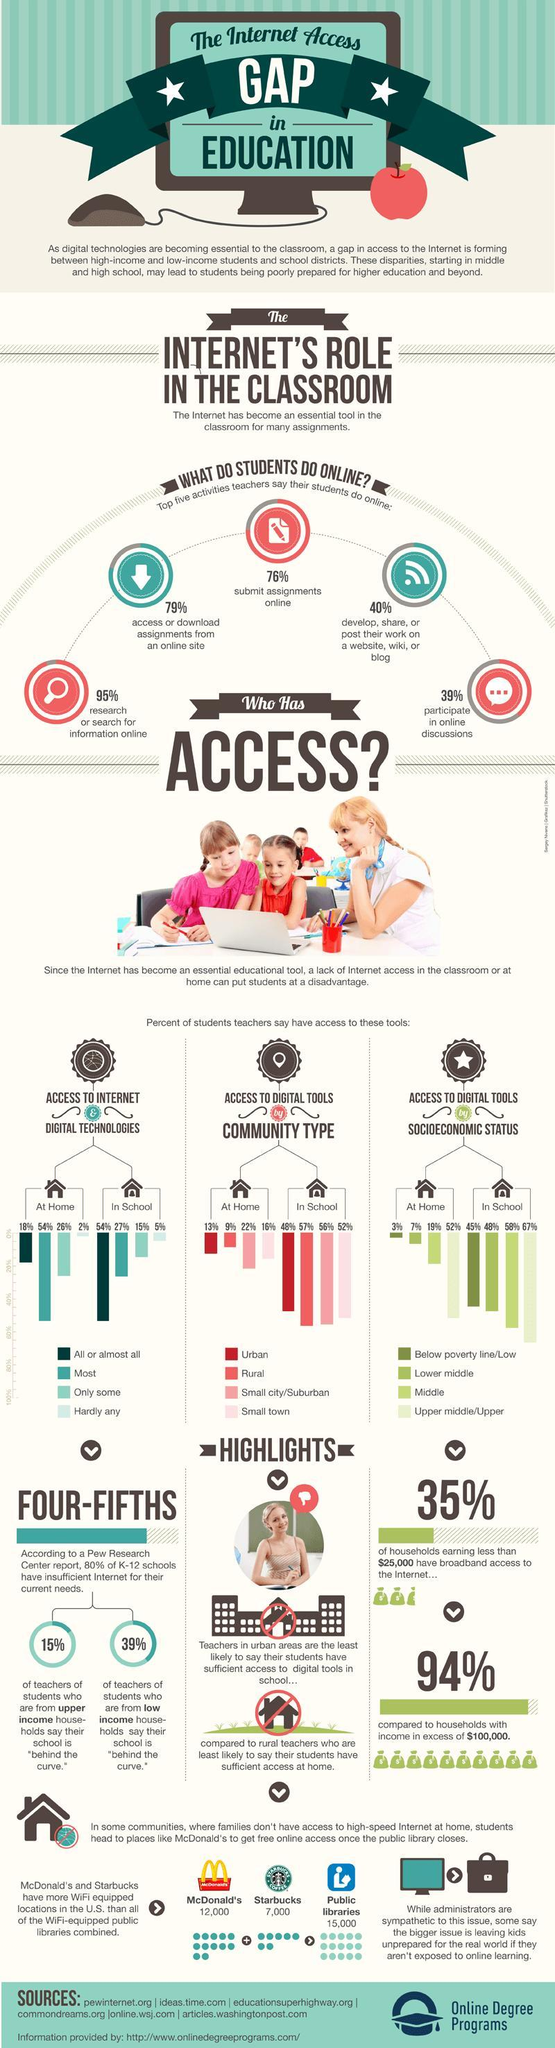What percentage of U.S.students have hardly any access to digital technologies at schools?
Answer the question with a short phrase. 5% What percentage of U.S.students have access to all kind of digital technologies at their home? 18% What percentage of U.S.students in schools are below the poverty line? 45% What percentage of U.S. students research or search for online informations? 95% What percentage of U.S.students in schools belong to the upper middle/upper class category? 67% What percentage of U.S. students who go to the school located in a small town has access to digital tools? 52% What percentage of U.S.students who go to the school located in an urban region has access to digital tools? 48% What percentage of students participate in online discussion in the U.S? 39% How many WiFi equipped public libraries are available in the U.S.? 15,000 How many Starbucks in the U.S. are WiFi equipped? 7,000 